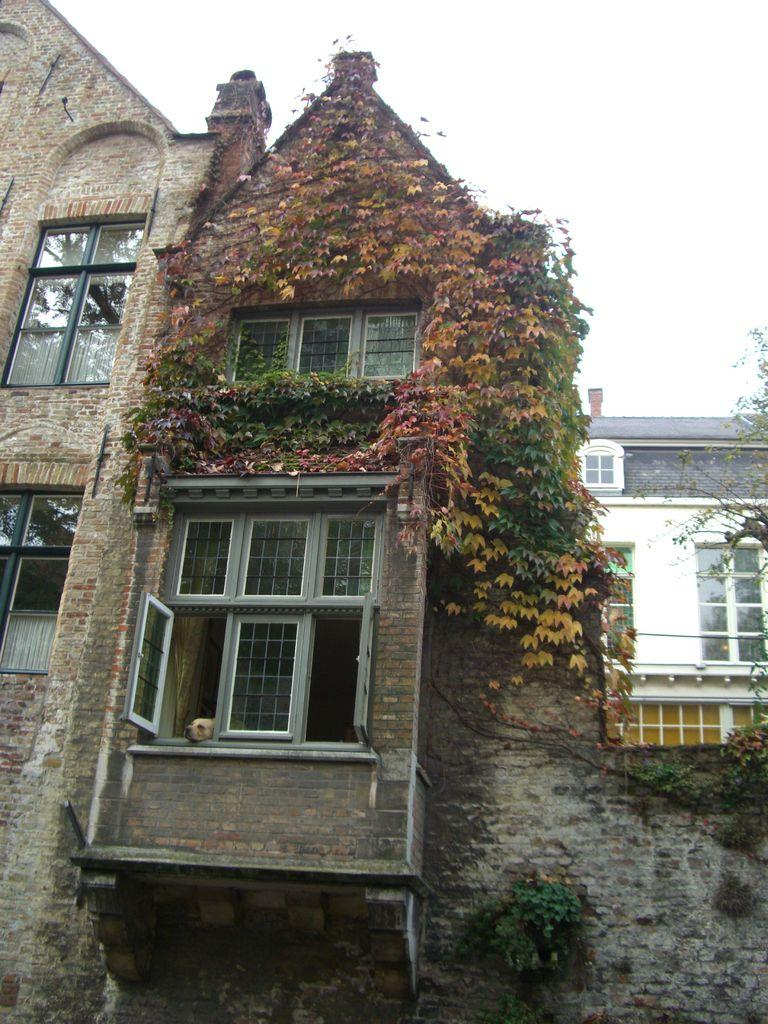What type of structures are present in the image? There are buildings in the image. What is growing on the buildings? There are plants on the buildings. What type of vegetation can be seen in the image? There are trees in the image. Can you describe the presence of an animal in the image? There is a dog near a window in the image. What sense is the dog using to interact with the water in the image? There is no water present in the image, so the dog is not interacting with water. 